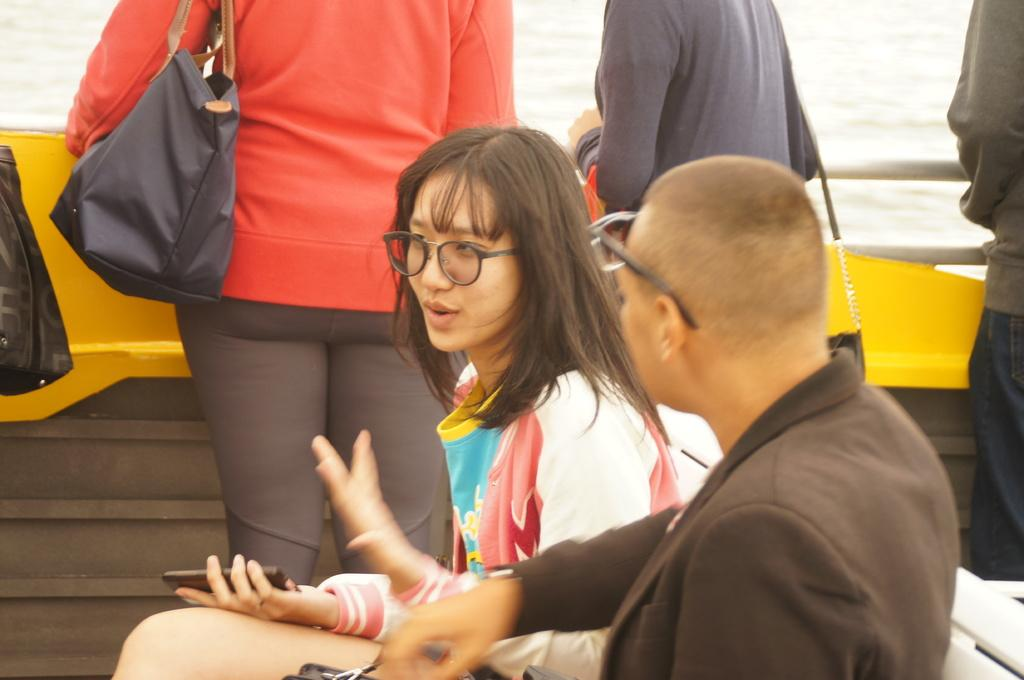Who is present in the image? There is a man and a woman in the image. What are they doing in the image? They are sitting inside a boat and talking to each other. What can be observed about their appearance? Both the man and the woman are wearing glasses. Are there any other people in the image? Yes, there are people standing behind them. Where is the boat located? The boat is on a sea. What laborer-related tasks are being performed by the man and woman in the image? There is no indication of any laborer-related tasks being performed in the image; they are simply sitting in a boat and talking to each other. What songs are being sung by the people standing behind them in the image? There is no indication of any singing or songs in the image; the people are simply standing behind the man and woman in the boat. 